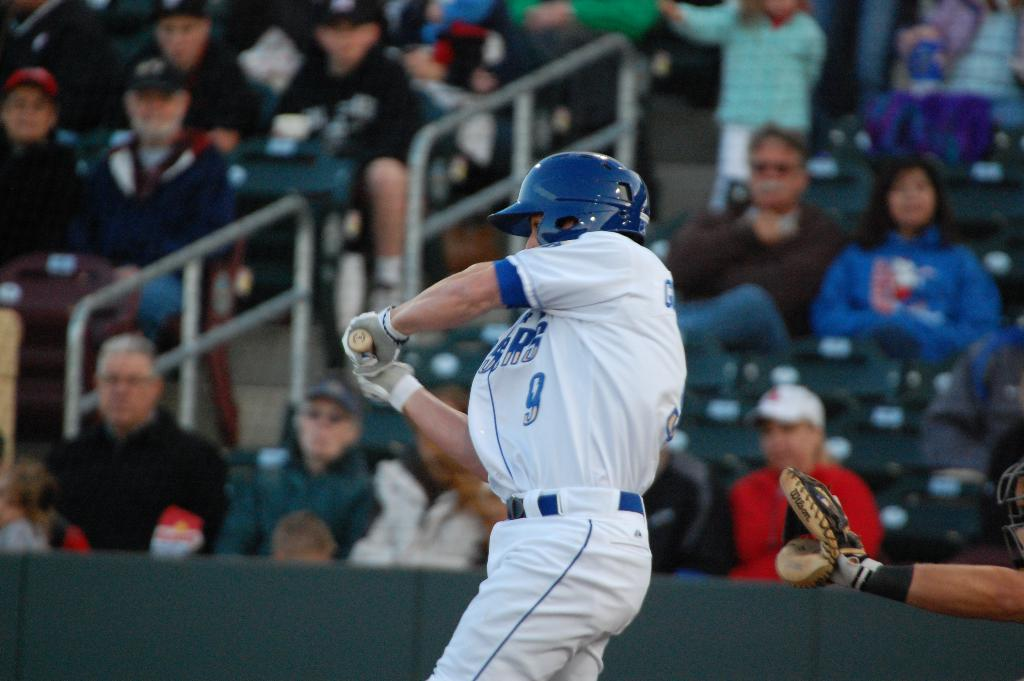<image>
Present a compact description of the photo's key features. A man wearing a blue and white baseball jersey with a number nine swings his bat. 